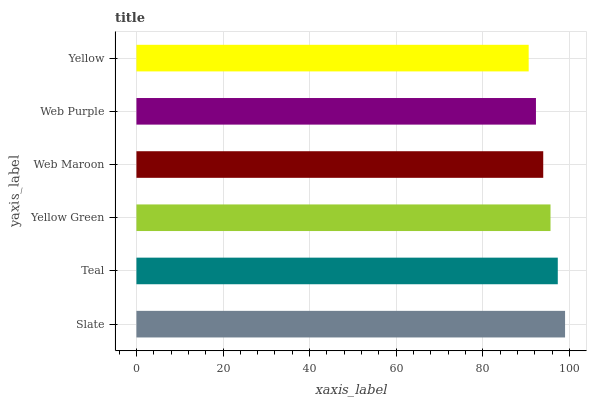Is Yellow the minimum?
Answer yes or no. Yes. Is Slate the maximum?
Answer yes or no. Yes. Is Teal the minimum?
Answer yes or no. No. Is Teal the maximum?
Answer yes or no. No. Is Slate greater than Teal?
Answer yes or no. Yes. Is Teal less than Slate?
Answer yes or no. Yes. Is Teal greater than Slate?
Answer yes or no. No. Is Slate less than Teal?
Answer yes or no. No. Is Yellow Green the high median?
Answer yes or no. Yes. Is Web Maroon the low median?
Answer yes or no. Yes. Is Web Purple the high median?
Answer yes or no. No. Is Slate the low median?
Answer yes or no. No. 